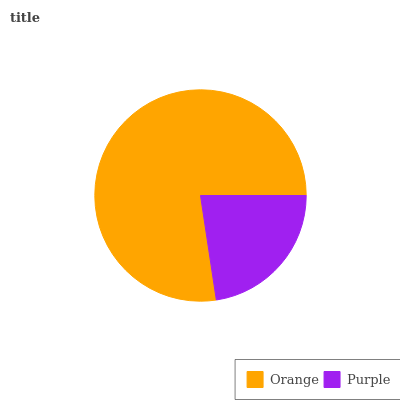Is Purple the minimum?
Answer yes or no. Yes. Is Orange the maximum?
Answer yes or no. Yes. Is Purple the maximum?
Answer yes or no. No. Is Orange greater than Purple?
Answer yes or no. Yes. Is Purple less than Orange?
Answer yes or no. Yes. Is Purple greater than Orange?
Answer yes or no. No. Is Orange less than Purple?
Answer yes or no. No. Is Orange the high median?
Answer yes or no. Yes. Is Purple the low median?
Answer yes or no. Yes. Is Purple the high median?
Answer yes or no. No. Is Orange the low median?
Answer yes or no. No. 